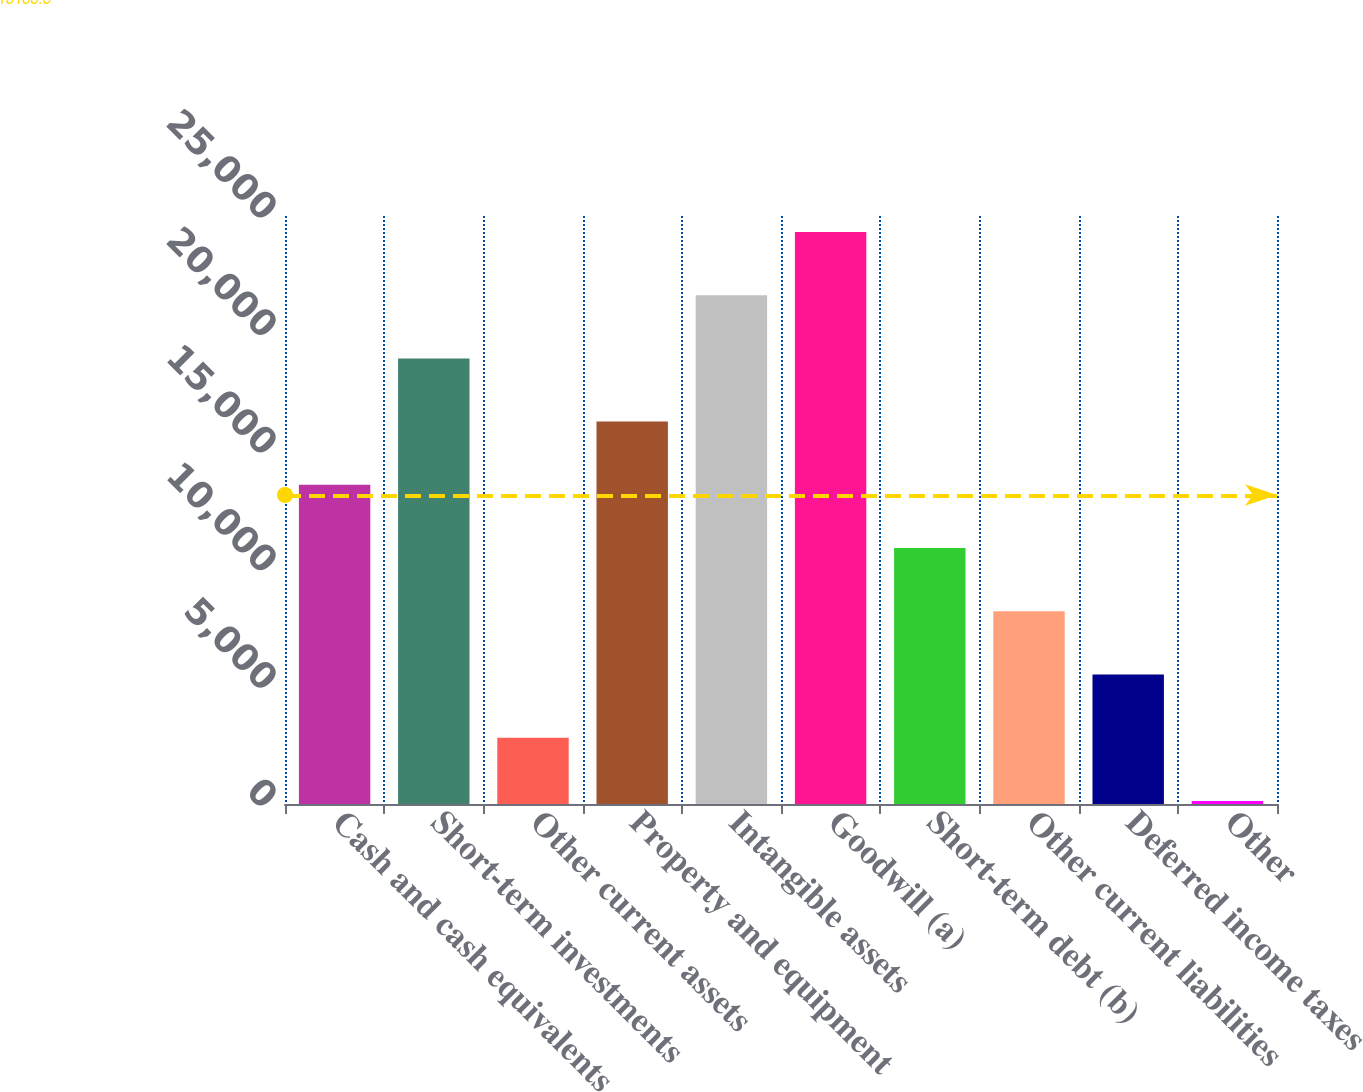<chart> <loc_0><loc_0><loc_500><loc_500><bar_chart><fcel>Cash and cash equivalents<fcel>Short-term investments<fcel>Other current assets<fcel>Property and equipment<fcel>Intangible assets<fcel>Goodwill (a)<fcel>Short-term debt (b)<fcel>Other current liabilities<fcel>Deferred income taxes<fcel>Other<nl><fcel>13570<fcel>18945.6<fcel>2818.8<fcel>16257.8<fcel>21633.4<fcel>24321.2<fcel>10882.2<fcel>8194.4<fcel>5506.6<fcel>131<nl></chart> 